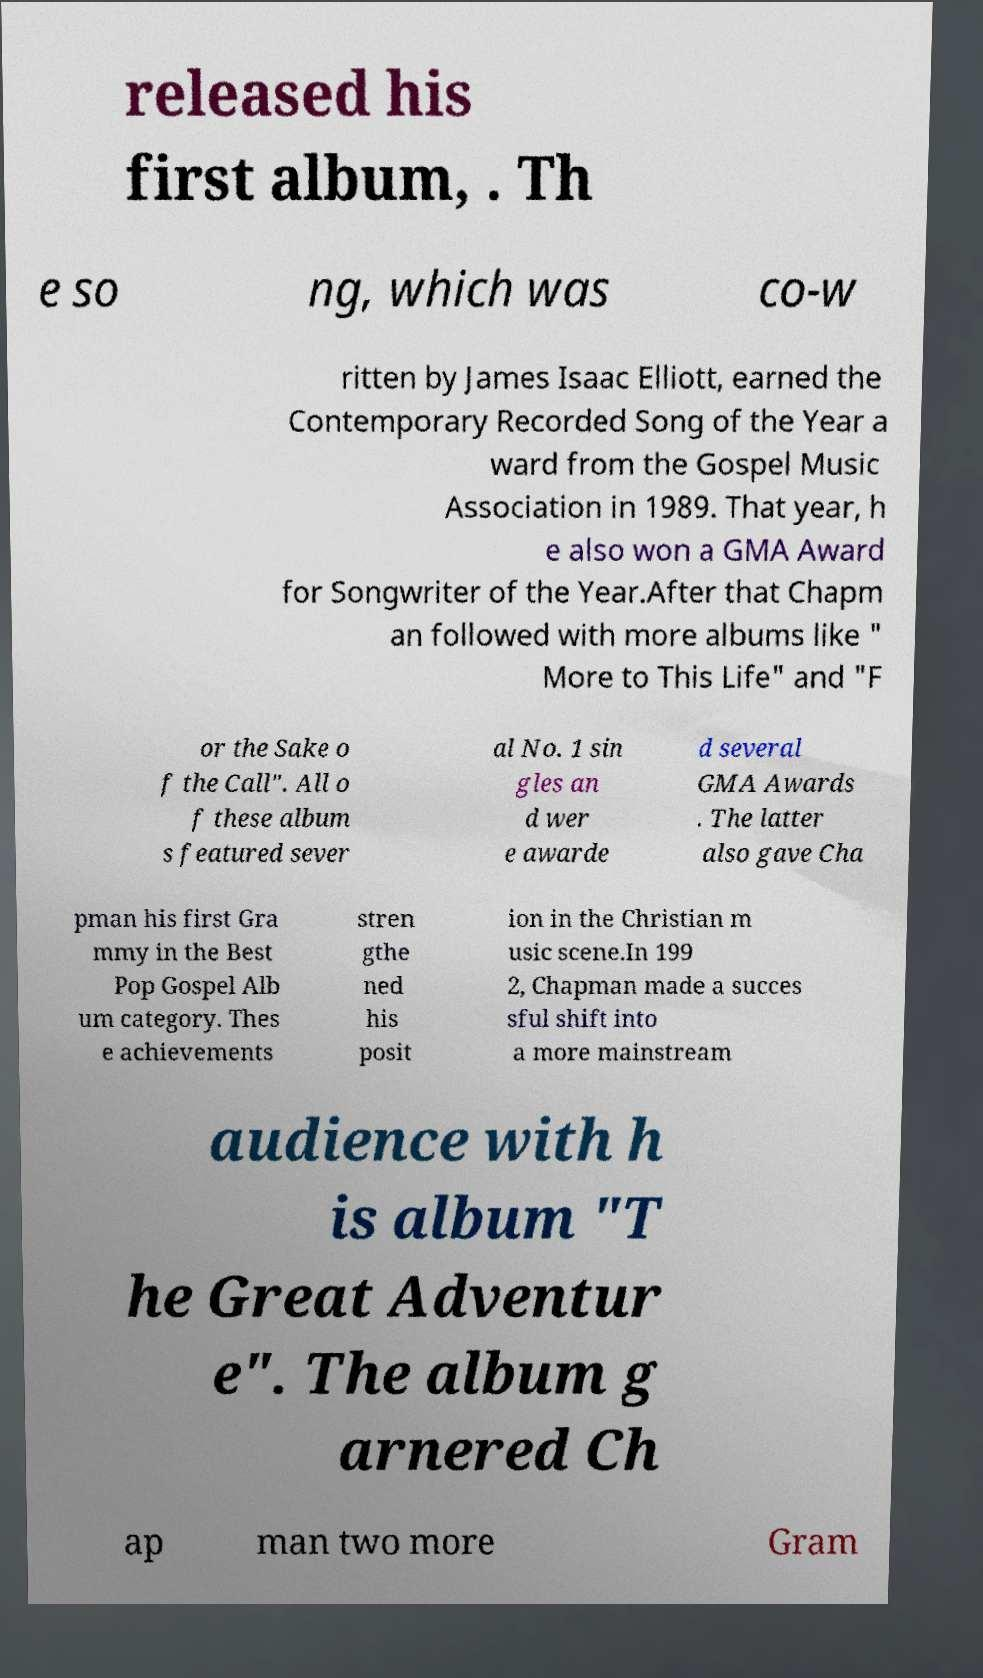Could you extract and type out the text from this image? released his first album, . Th e so ng, which was co-w ritten by James Isaac Elliott, earned the Contemporary Recorded Song of the Year a ward from the Gospel Music Association in 1989. That year, h e also won a GMA Award for Songwriter of the Year.After that Chapm an followed with more albums like " More to This Life" and "F or the Sake o f the Call". All o f these album s featured sever al No. 1 sin gles an d wer e awarde d several GMA Awards . The latter also gave Cha pman his first Gra mmy in the Best Pop Gospel Alb um category. Thes e achievements stren gthe ned his posit ion in the Christian m usic scene.In 199 2, Chapman made a succes sful shift into a more mainstream audience with h is album "T he Great Adventur e". The album g arnered Ch ap man two more Gram 